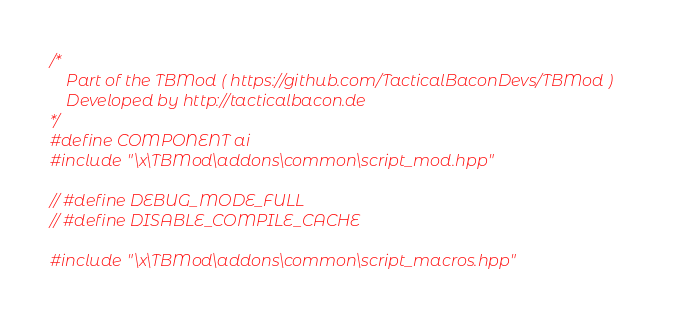<code> <loc_0><loc_0><loc_500><loc_500><_C++_>/*
    Part of the TBMod ( https://github.com/TacticalBaconDevs/TBMod )
    Developed by http://tacticalbacon.de
*/
#define COMPONENT ai
#include "\x\TBMod\addons\common\script_mod.hpp"

// #define DEBUG_MODE_FULL
// #define DISABLE_COMPILE_CACHE

#include "\x\TBMod\addons\common\script_macros.hpp"
</code> 